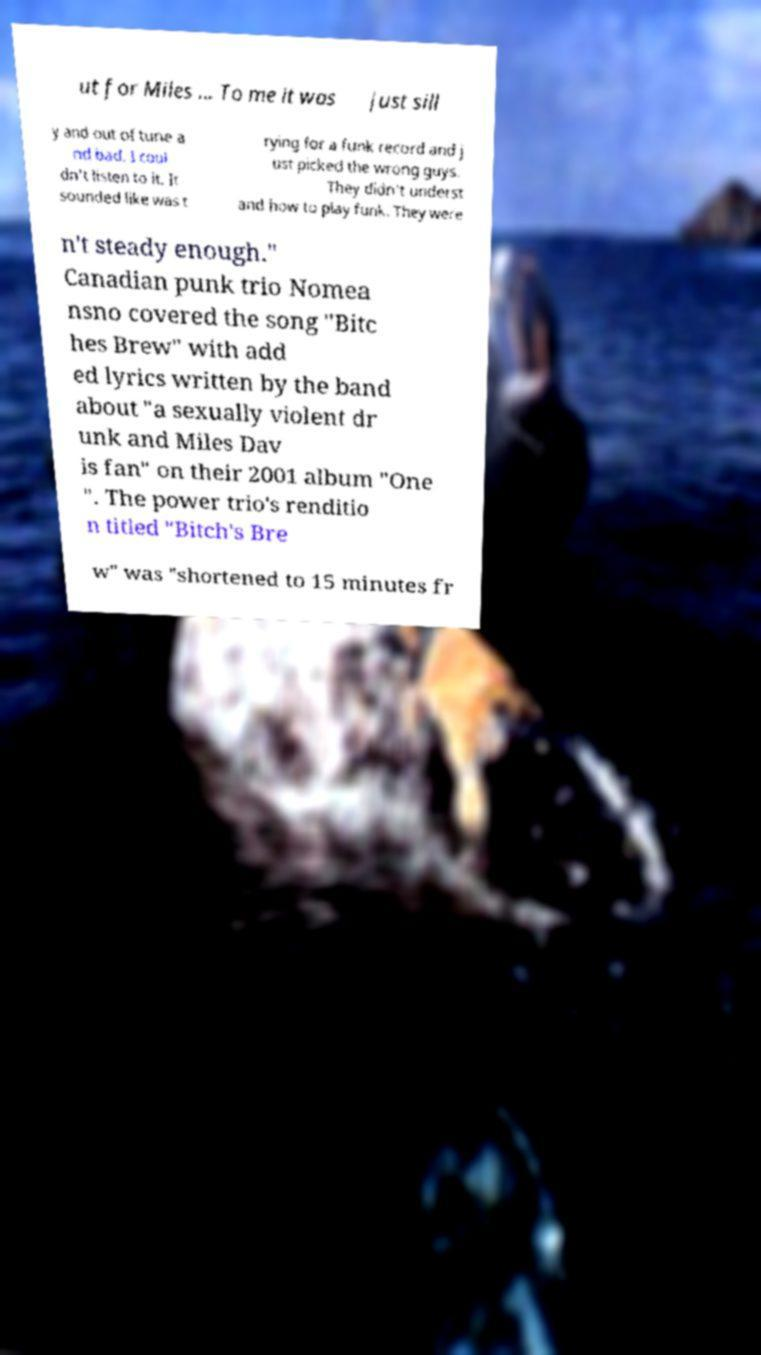Could you extract and type out the text from this image? ut for Miles ... To me it was just sill y and out of tune a nd bad. I coul dn't listen to it. It sounded like was t rying for a funk record and j ust picked the wrong guys. They didn't underst and how to play funk. They were n't steady enough." Canadian punk trio Nomea nsno covered the song "Bitc hes Brew" with add ed lyrics written by the band about "a sexually violent dr unk and Miles Dav is fan" on their 2001 album "One ". The power trio's renditio n titled "Bitch's Bre w" was "shortened to 15 minutes fr 